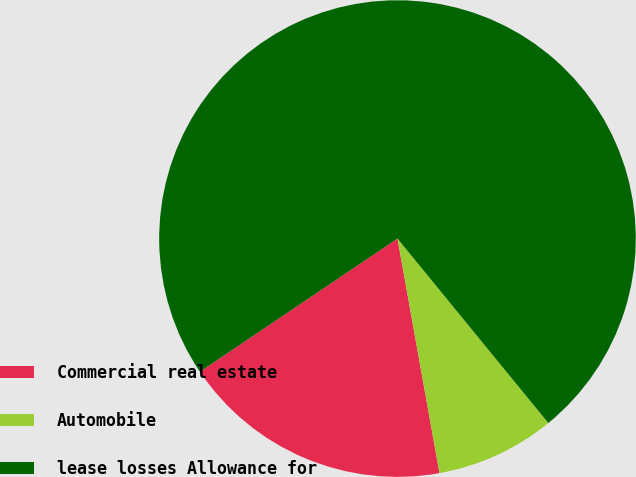Convert chart to OTSL. <chart><loc_0><loc_0><loc_500><loc_500><pie_chart><fcel>Commercial real estate<fcel>Automobile<fcel>lease losses Allowance for<nl><fcel>18.38%<fcel>8.09%<fcel>73.53%<nl></chart> 